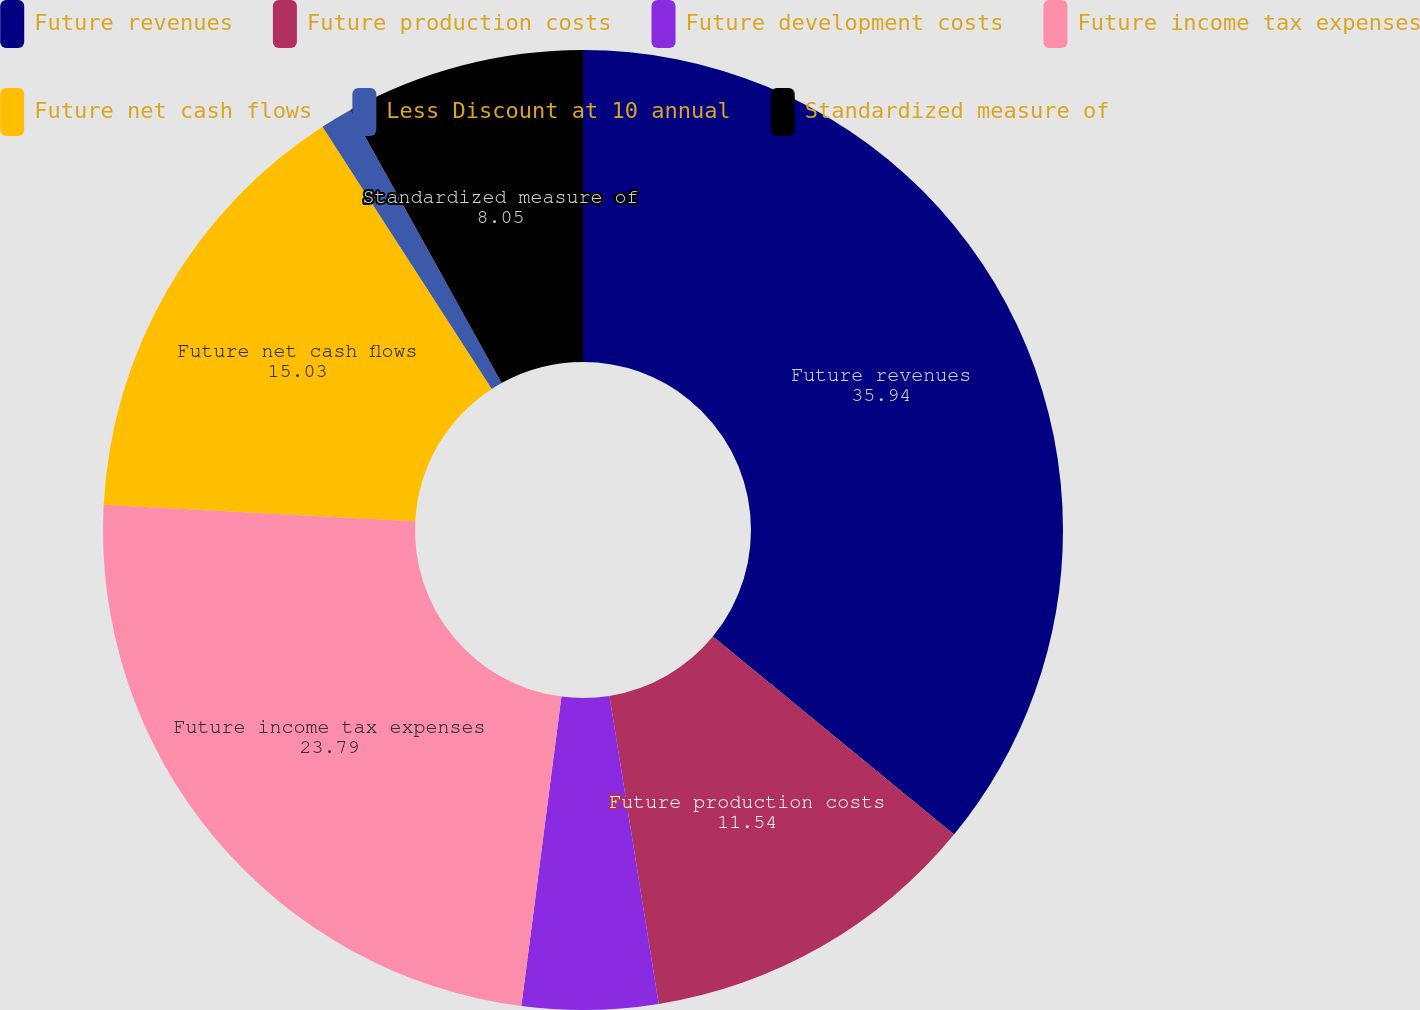<chart> <loc_0><loc_0><loc_500><loc_500><pie_chart><fcel>Future revenues<fcel>Future production costs<fcel>Future development costs<fcel>Future income tax expenses<fcel>Future net cash flows<fcel>Less Discount at 10 annual<fcel>Standardized measure of<nl><fcel>35.94%<fcel>11.54%<fcel>4.57%<fcel>23.79%<fcel>15.03%<fcel>1.08%<fcel>8.05%<nl></chart> 